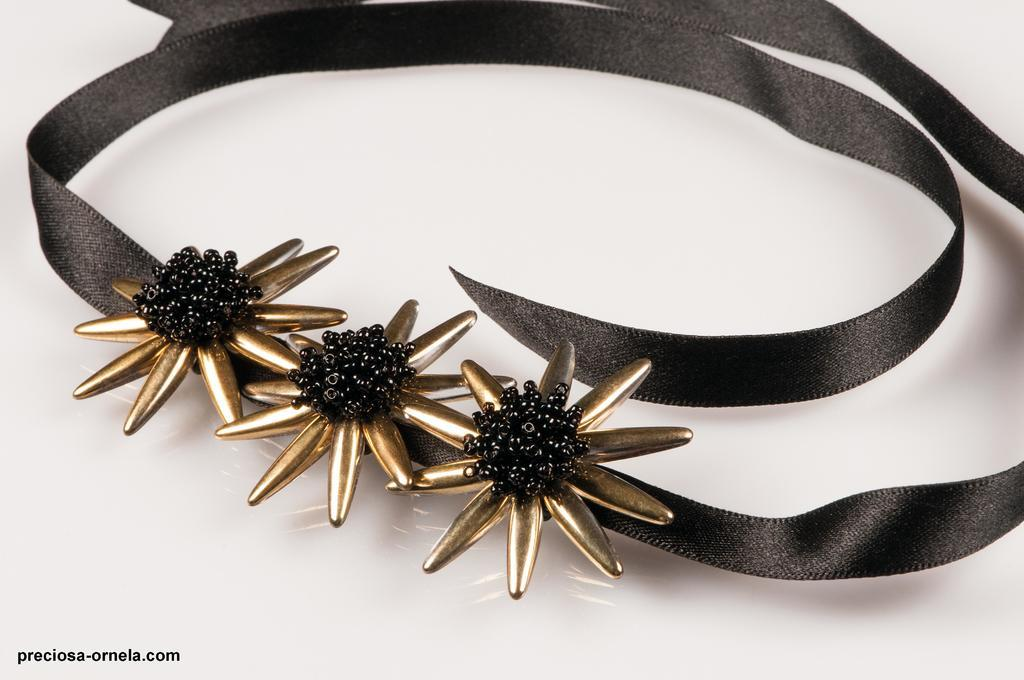What type of object is in the image? There is an ornament in the image. How does the ornament appear? The ornament resembles a ribbon. What color is the ornament? The ornament is black in color. Where is the ornament located? The ornament is placed on a desk. How many suits are hanging on the ornament in the image? There are no suits present in the image; the ornament resembles a ribbon and is black in color. 